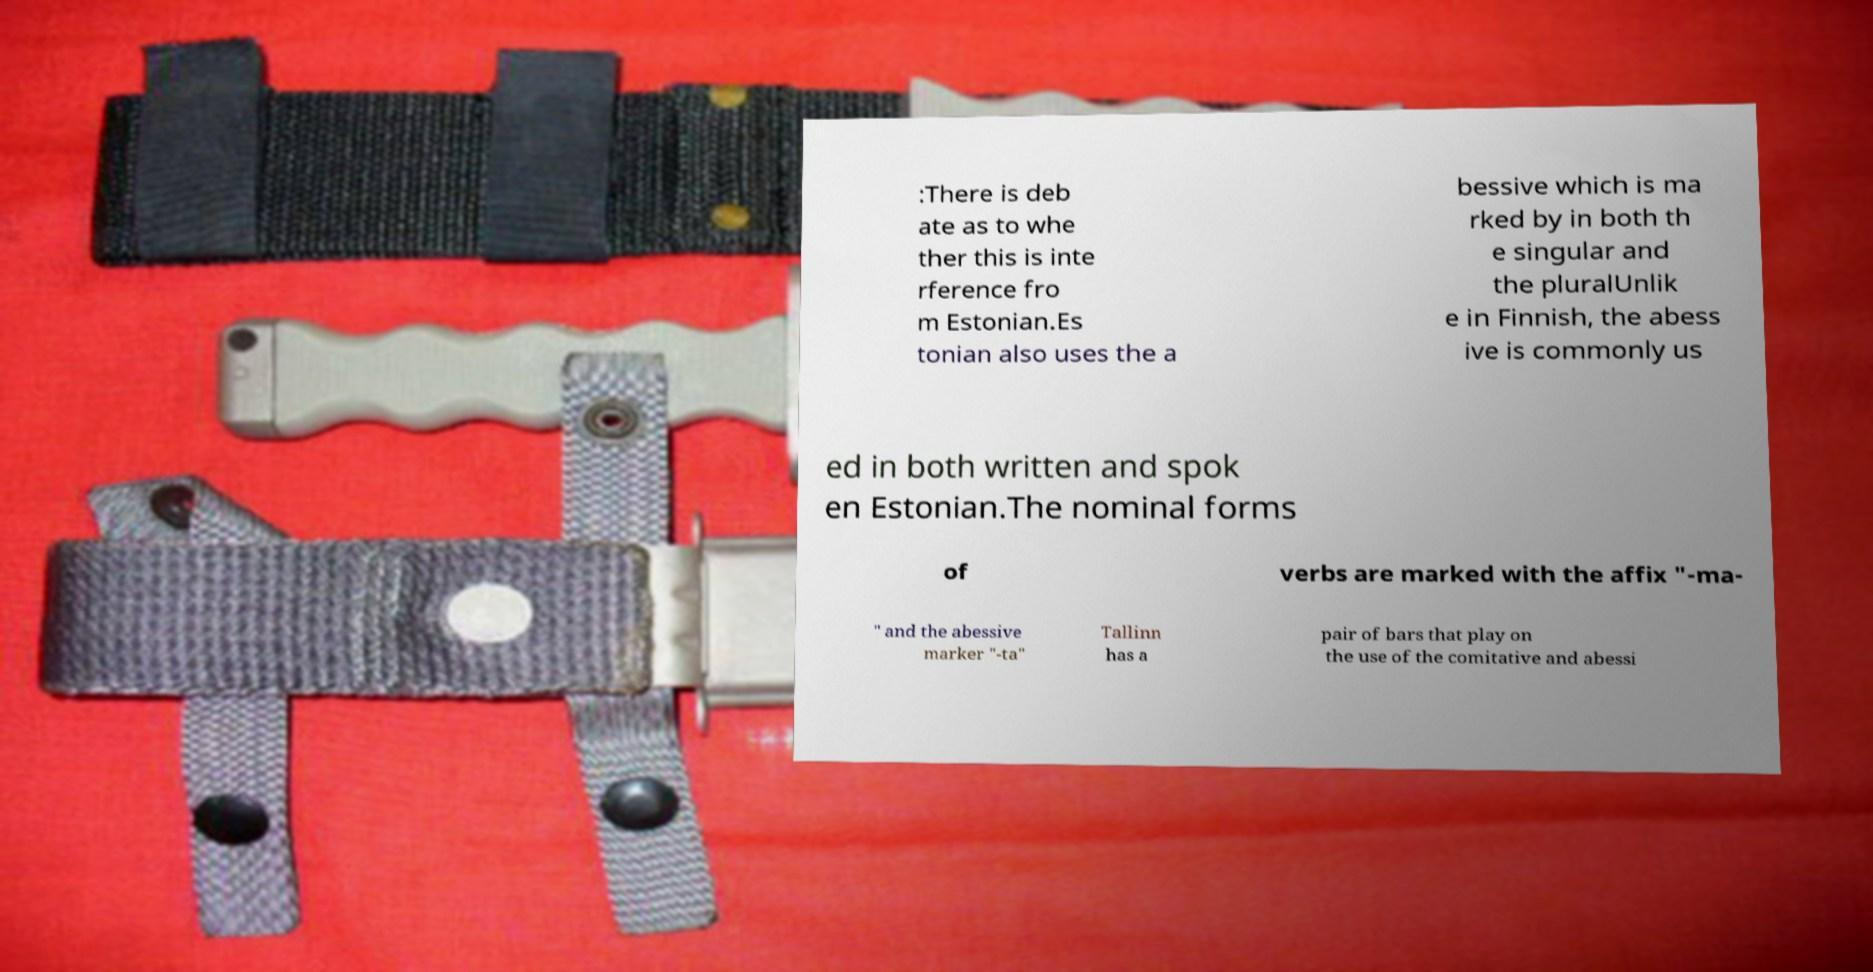Could you extract and type out the text from this image? :There is deb ate as to whe ther this is inte rference fro m Estonian.Es tonian also uses the a bessive which is ma rked by in both th e singular and the pluralUnlik e in Finnish, the abess ive is commonly us ed in both written and spok en Estonian.The nominal forms of verbs are marked with the affix "-ma- " and the abessive marker "-ta" Tallinn has a pair of bars that play on the use of the comitative and abessi 